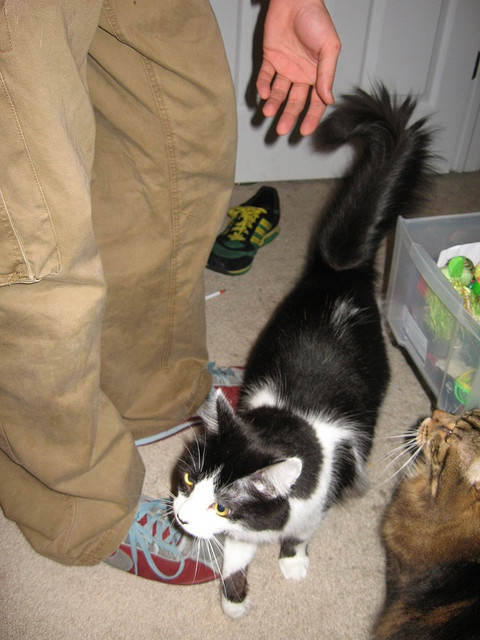Describe the objects in this image and their specific colors. I can see people in gray and tan tones, cat in gray, black, white, and darkgray tones, and cat in gray, black, and maroon tones in this image. 